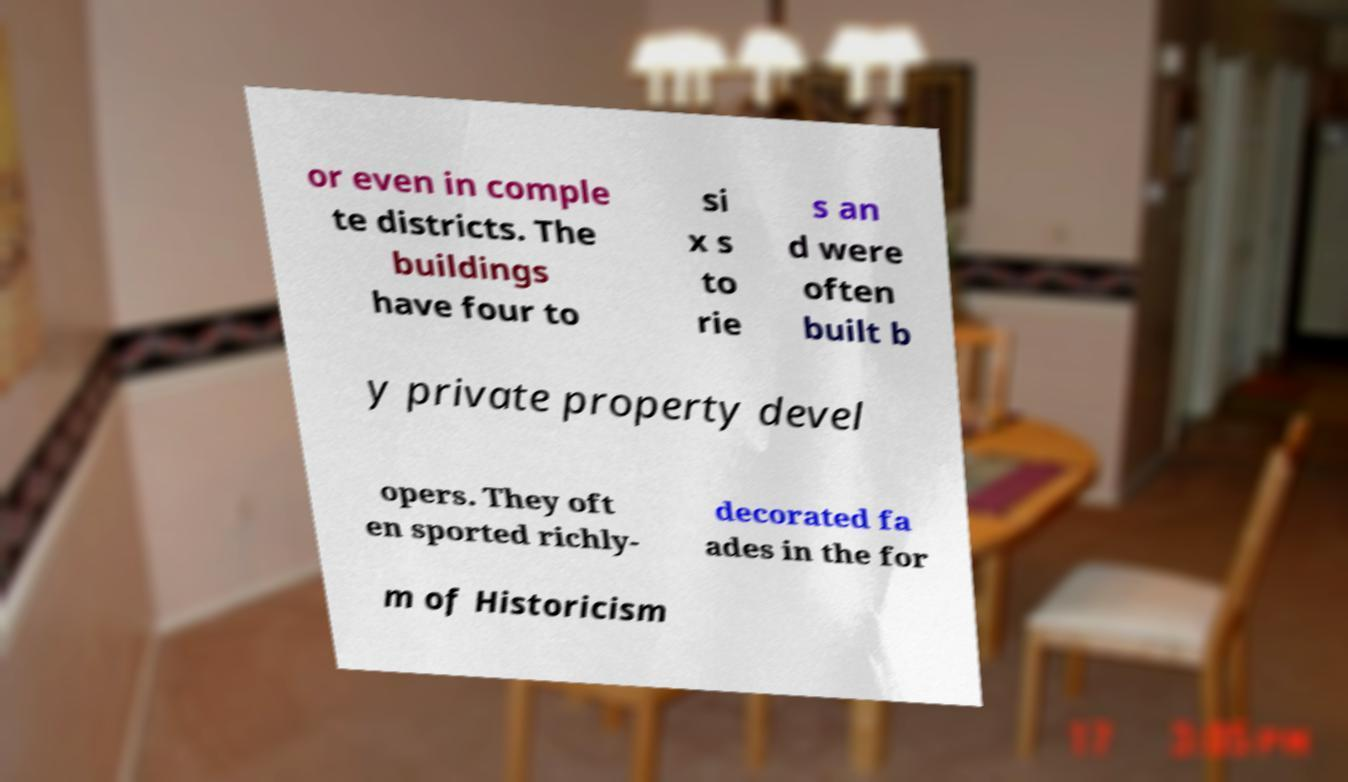What messages or text are displayed in this image? I need them in a readable, typed format. or even in comple te districts. The buildings have four to si x s to rie s an d were often built b y private property devel opers. They oft en sported richly- decorated fa ades in the for m of Historicism 